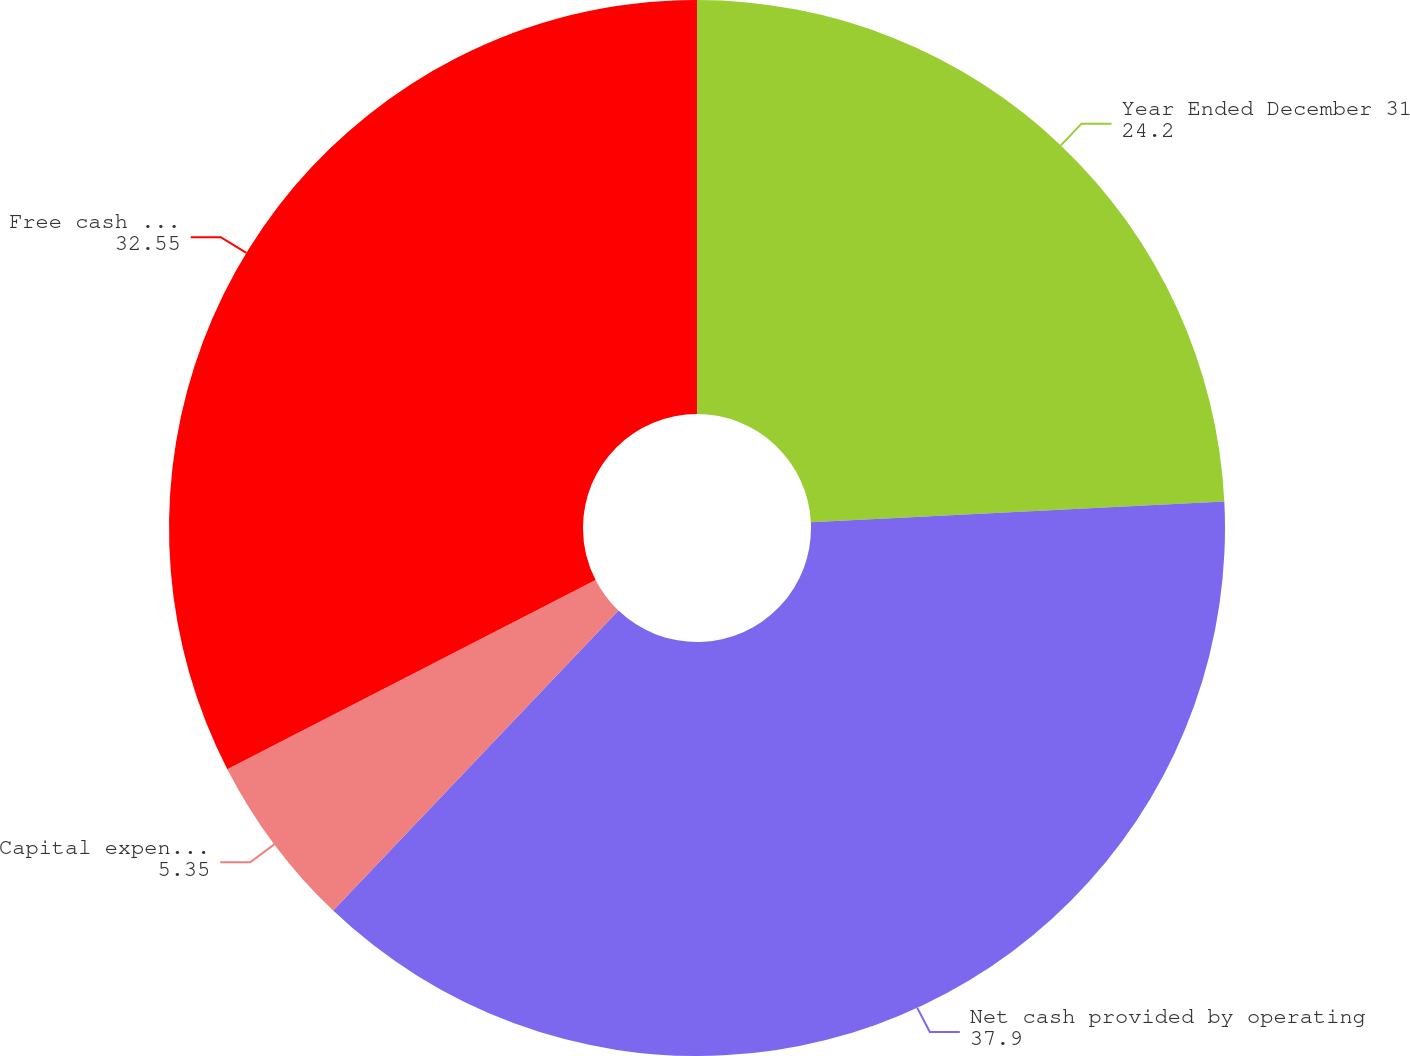Convert chart. <chart><loc_0><loc_0><loc_500><loc_500><pie_chart><fcel>Year Ended December 31<fcel>Net cash provided by operating<fcel>Capital expenditures<fcel>Free cash flow from operations<nl><fcel>24.2%<fcel>37.9%<fcel>5.35%<fcel>32.55%<nl></chart> 